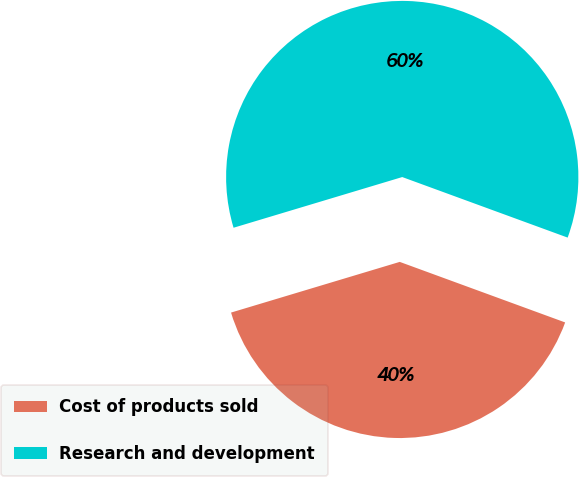<chart> <loc_0><loc_0><loc_500><loc_500><pie_chart><fcel>Cost of products sold<fcel>Research and development<nl><fcel>39.77%<fcel>60.23%<nl></chart> 